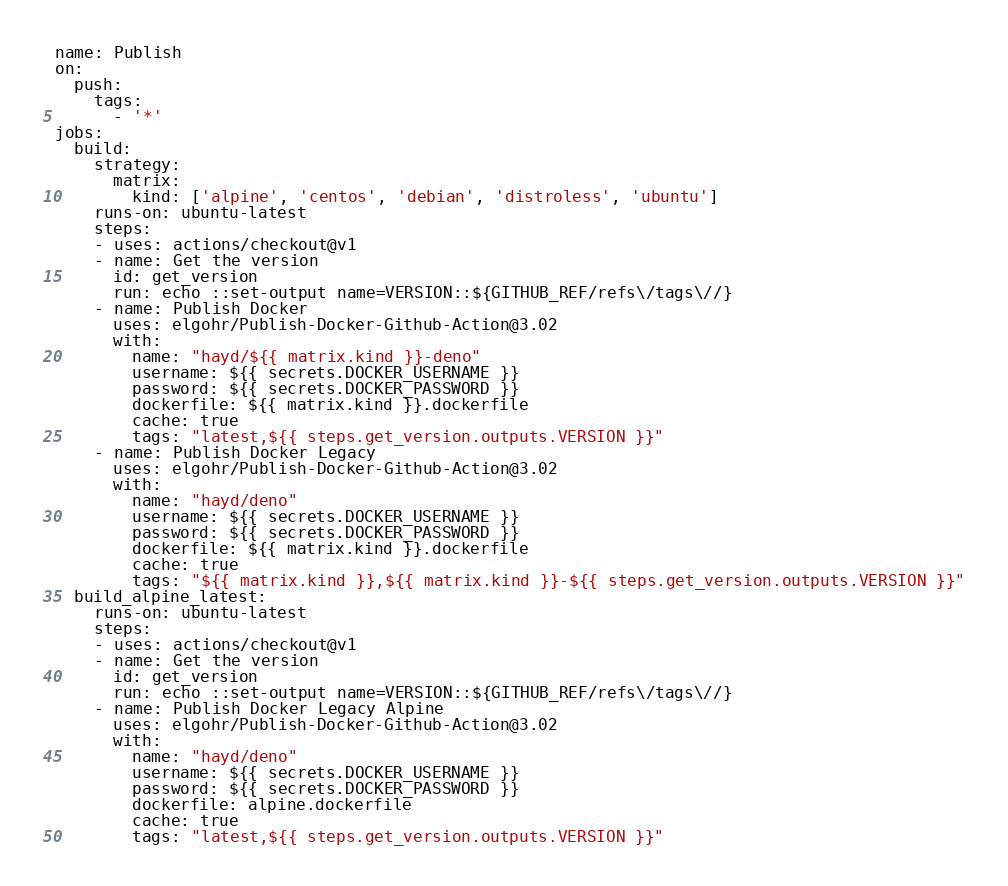<code> <loc_0><loc_0><loc_500><loc_500><_YAML_>name: Publish
on:
  push:
    tags:
      - '*'
jobs:
  build:
    strategy:
      matrix:
        kind: ['alpine', 'centos', 'debian', 'distroless', 'ubuntu']
    runs-on: ubuntu-latest
    steps:
    - uses: actions/checkout@v1
    - name: Get the version
      id: get_version
      run: echo ::set-output name=VERSION::${GITHUB_REF/refs\/tags\//}
    - name: Publish Docker
      uses: elgohr/Publish-Docker-Github-Action@3.02
      with:
        name: "hayd/${{ matrix.kind }}-deno"
        username: ${{ secrets.DOCKER_USERNAME }}
        password: ${{ secrets.DOCKER_PASSWORD }}
        dockerfile: ${{ matrix.kind }}.dockerfile
        cache: true
        tags: "latest,${{ steps.get_version.outputs.VERSION }}"
    - name: Publish Docker Legacy
      uses: elgohr/Publish-Docker-Github-Action@3.02
      with:
        name: "hayd/deno"
        username: ${{ secrets.DOCKER_USERNAME }}
        password: ${{ secrets.DOCKER_PASSWORD }}
        dockerfile: ${{ matrix.kind }}.dockerfile
        cache: true
        tags: "${{ matrix.kind }},${{ matrix.kind }}-${{ steps.get_version.outputs.VERSION }}"
  build_alpine_latest:
    runs-on: ubuntu-latest
    steps:
    - uses: actions/checkout@v1
    - name: Get the version
      id: get_version
      run: echo ::set-output name=VERSION::${GITHUB_REF/refs\/tags\//}
    - name: Publish Docker Legacy Alpine
      uses: elgohr/Publish-Docker-Github-Action@3.02
      with:
        name: "hayd/deno"
        username: ${{ secrets.DOCKER_USERNAME }}
        password: ${{ secrets.DOCKER_PASSWORD }}
        dockerfile: alpine.dockerfile
        cache: true
        tags: "latest,${{ steps.get_version.outputs.VERSION }}"
</code> 